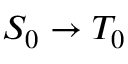Convert formula to latex. <formula><loc_0><loc_0><loc_500><loc_500>S _ { 0 } \rightarrow T _ { 0 }</formula> 